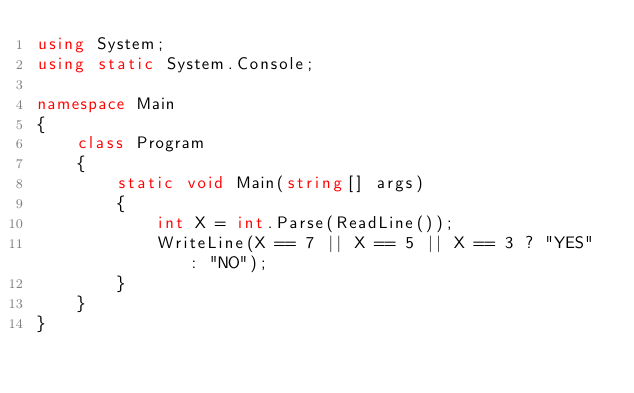Convert code to text. <code><loc_0><loc_0><loc_500><loc_500><_C#_>using System;
using static System.Console;

namespace Main
{
    class Program
    {
        static void Main(string[] args)
        {
            int X = int.Parse(ReadLine());
            WriteLine(X == 7 || X == 5 || X == 3 ? "YES" : "NO");
        }
    }
}</code> 